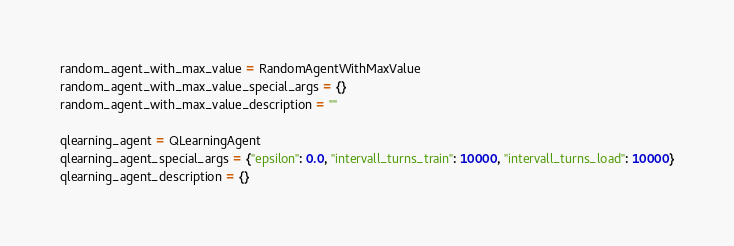<code> <loc_0><loc_0><loc_500><loc_500><_Python_>random_agent_with_max_value = RandomAgentWithMaxValue
random_agent_with_max_value_special_args = {}
random_agent_with_max_value_description = ""

qlearning_agent = QLearningAgent
qlearning_agent_special_args = {"epsilon": 0.0, "intervall_turns_train": 10000, "intervall_turns_load": 10000}
qlearning_agent_description = {}
</code> 